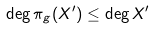Convert formula to latex. <formula><loc_0><loc_0><loc_500><loc_500>\deg \pi _ { g } ( X ^ { \prime } ) \leq \deg X ^ { \prime }</formula> 